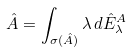Convert formula to latex. <formula><loc_0><loc_0><loc_500><loc_500>\hat { A } = \int _ { \sigma ( \hat { A } ) } \lambda \, d \hat { E } ^ { A } _ { \lambda }</formula> 